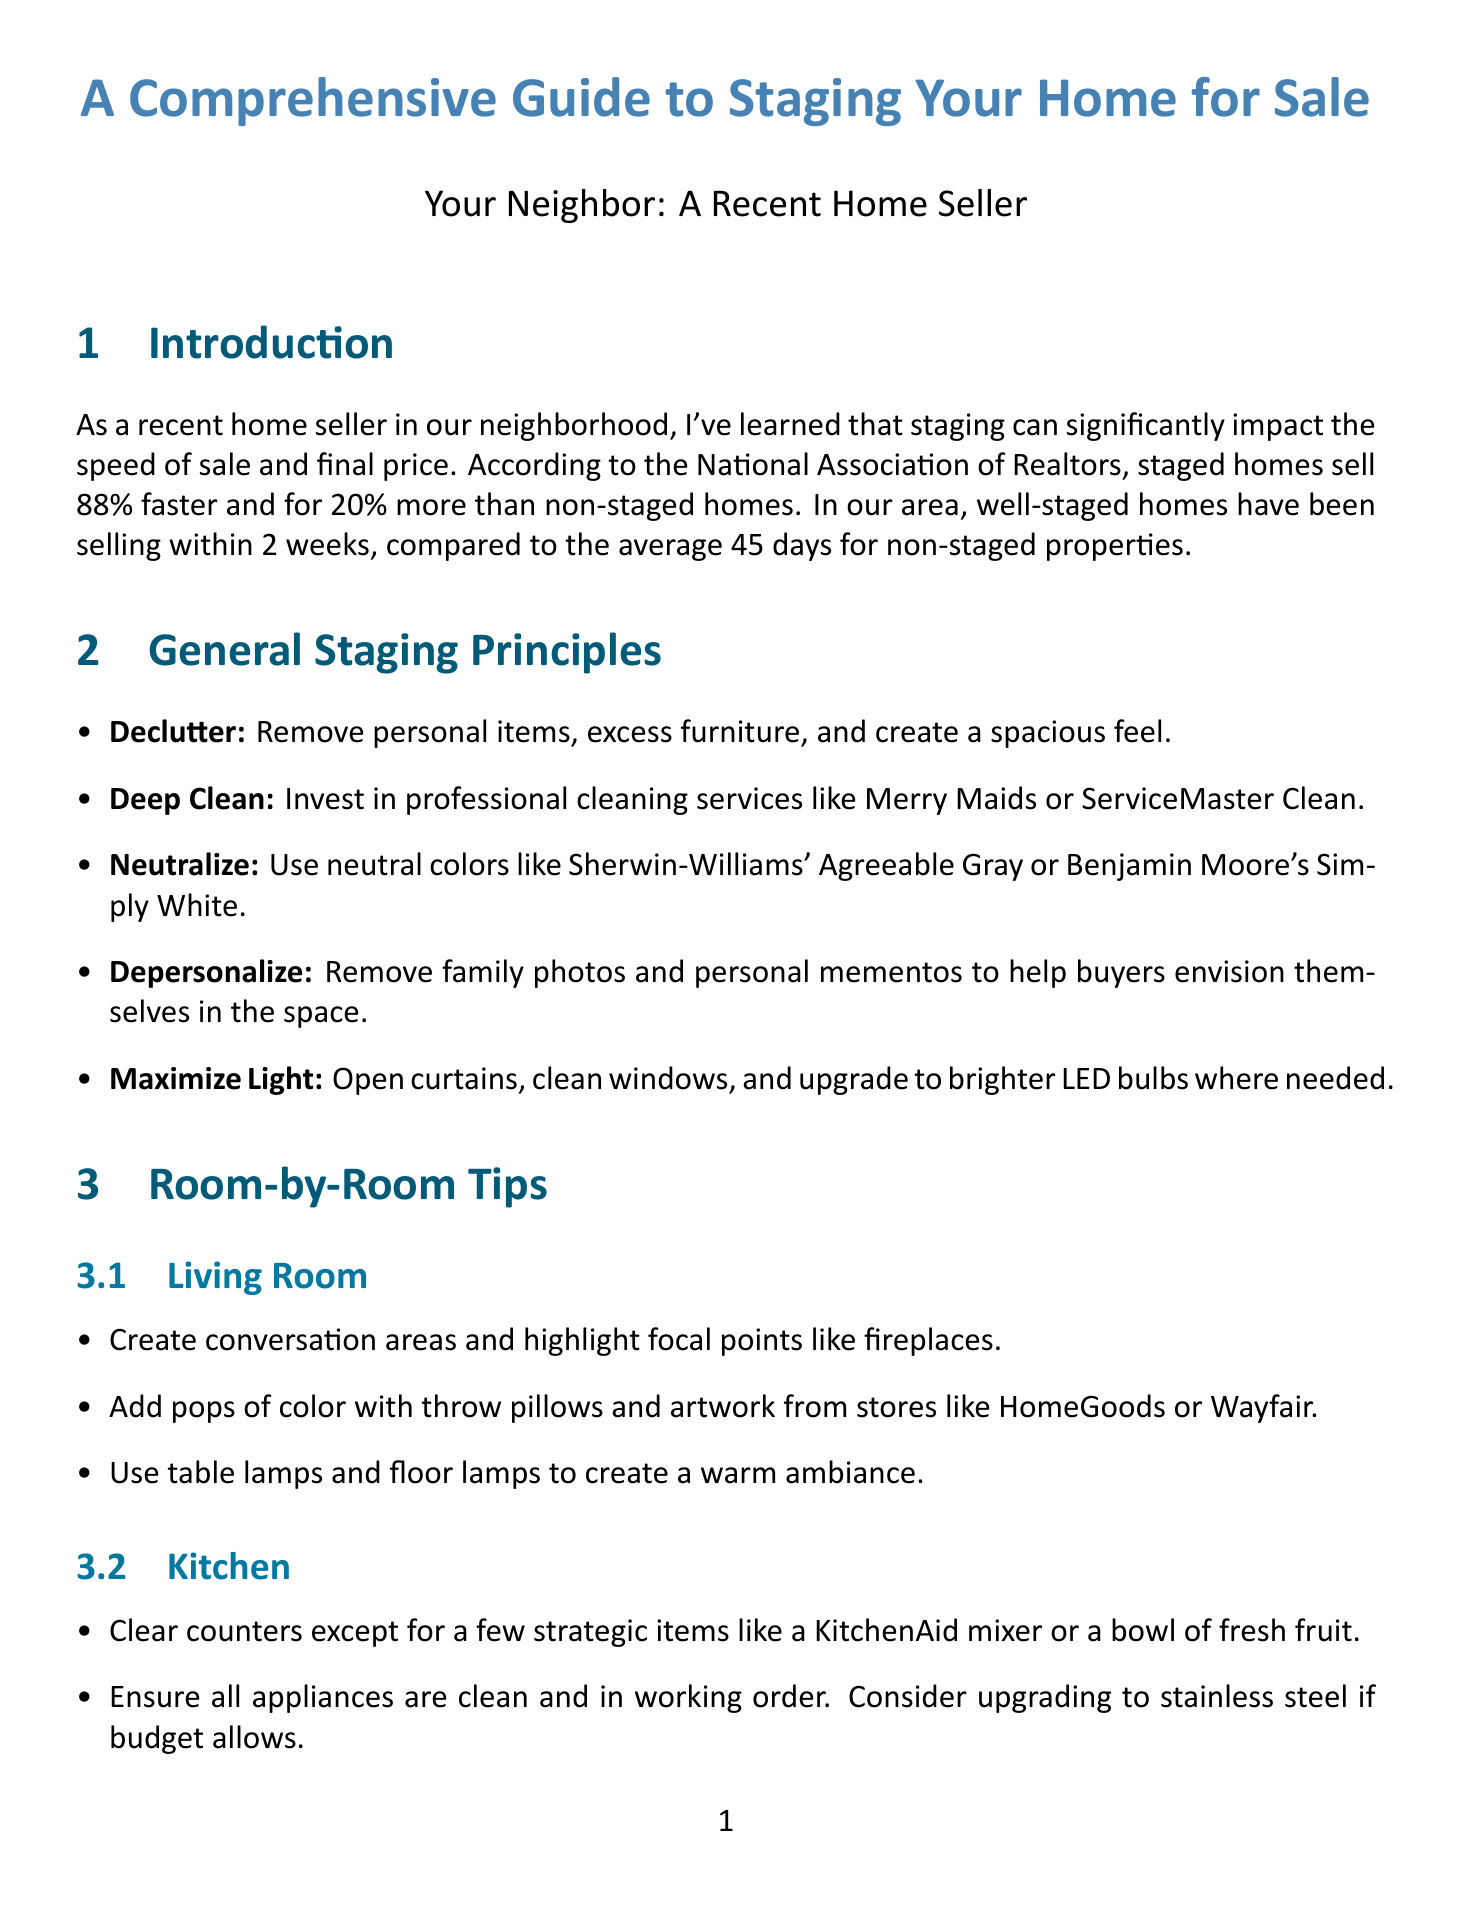what is the average selling time for well-staged homes in our area? The average selling time for well-staged homes in our area is mentioned as 2 weeks.
Answer: 2 weeks what is the ROI for staged homes according to the National Association of Realtors? The document states that staged homes sell for 20% more than non-staged homes.
Answer: 20% which color is recommended for neutralizing a room? The guide suggests using Sherwin-Williams' Agreeable Gray or Benjamin Moore's Simply White for neutralizing.
Answer: Agreeable Gray or Simply White which store offers affordable light fixtures? The document mentions IKEA or Wayfair as sources for affordable light fixtures.
Answer: IKEA or Wayfair what should you do with countertops in the kitchen during staging? The recommendation is to clear counters except for a few strategic items.
Answer: Clear counters which type of photography is suggested for listings? Professional photography from companies like VHT Studios is suggested for standout listing photos.
Answer: VHT Studios what should be used to create a warm ambiance in the living room? The guide recommends using table lamps and floor lamps for warm ambiance.
Answer: Table lamps and floor lamps how much can a fresh coat of paint transform a room? The document states that a fresh coat of paint can transform a room for under $100.
Answer: Under $100 